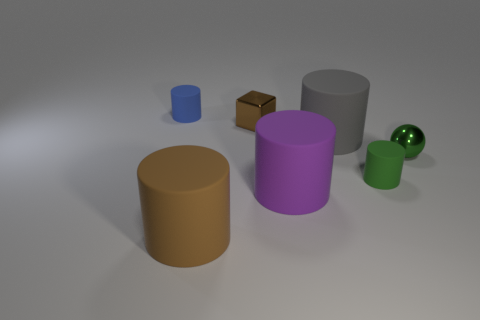What material is the small object that is the same color as the metal ball?
Your response must be concise. Rubber. There is a green thing that is to the left of the green sphere in front of the small blue matte thing; are there any small objects that are behind it?
Offer a terse response. Yes. Are there fewer purple cylinders that are behind the large gray cylinder than big gray matte things that are in front of the large brown rubber cylinder?
Your answer should be compact. No. The ball that is made of the same material as the brown cube is what color?
Keep it short and to the point. Green. There is a cylinder to the left of the object in front of the big purple matte cylinder; what is its color?
Provide a succinct answer. Blue. Is there a tiny matte object that has the same color as the tiny metal cube?
Your answer should be compact. No. There is a brown shiny thing that is the same size as the green sphere; what shape is it?
Give a very brief answer. Cube. There is a tiny cylinder that is behind the gray matte thing; how many small blocks are on the right side of it?
Your answer should be very brief. 1. Is the color of the shiny cube the same as the metal ball?
Keep it short and to the point. No. How many other objects are there of the same material as the large gray object?
Make the answer very short. 4. 